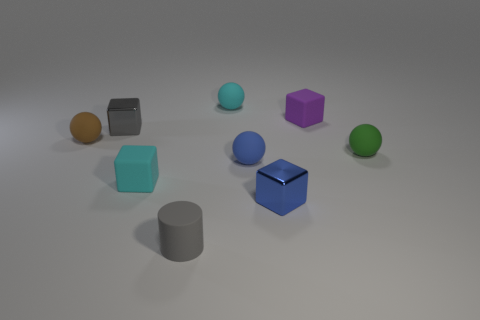Subtract 1 cubes. How many cubes are left? 3 Add 1 large purple cubes. How many objects exist? 10 Subtract all yellow balls. Subtract all blue cubes. How many balls are left? 4 Subtract all cylinders. How many objects are left? 8 Add 5 small green spheres. How many small green spheres are left? 6 Add 7 big blue cubes. How many big blue cubes exist? 7 Subtract 0 yellow cubes. How many objects are left? 9 Subtract all purple blocks. Subtract all tiny purple blocks. How many objects are left? 7 